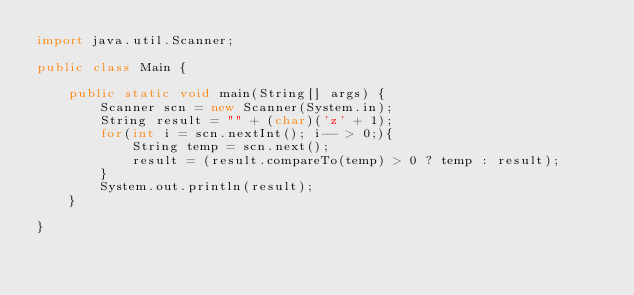<code> <loc_0><loc_0><loc_500><loc_500><_Java_>import java.util.Scanner;

public class Main {

	public static void main(String[] args) {
		Scanner scn = new Scanner(System.in);
		String result = "" + (char)('z' + 1);
		for(int i = scn.nextInt(); i-- > 0;){
			String temp = scn.next();
			result = (result.compareTo(temp) > 0 ? temp : result);
		}
		System.out.println(result);
	}

}</code> 